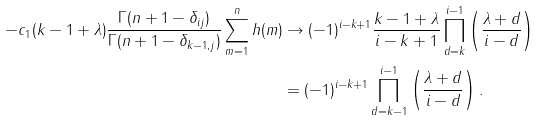<formula> <loc_0><loc_0><loc_500><loc_500>- c _ { 1 } ( k - 1 + \lambda ) \frac { \Gamma ( n + 1 - \delta _ { i j } ) } { \Gamma ( n + 1 - \delta _ { k - 1 , j } ) } \sum _ { m = 1 } ^ { n } h ( m ) & \rightarrow ( - 1 ) ^ { i - k + 1 } \frac { k - 1 + \lambda } { i - k + 1 } \prod _ { d = k } ^ { i - 1 } \left ( \frac { \lambda + d } { i - d } \right ) \\ & = ( - 1 ) ^ { i - k + 1 } \prod _ { d = k - 1 } ^ { i - 1 } \left ( \frac { \lambda + d } { i - d } \right ) .</formula> 